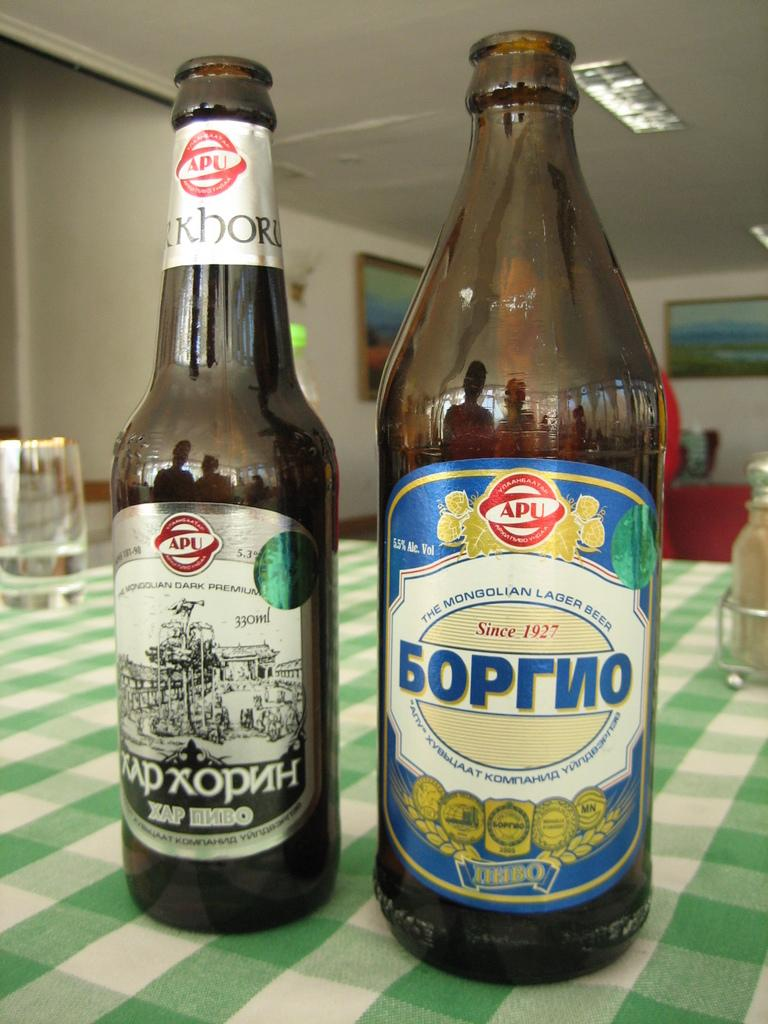<image>
Describe the image concisely. Two bottles of Mongolian lager which are empty, stand side by side on a green and white chequered table cloth. 